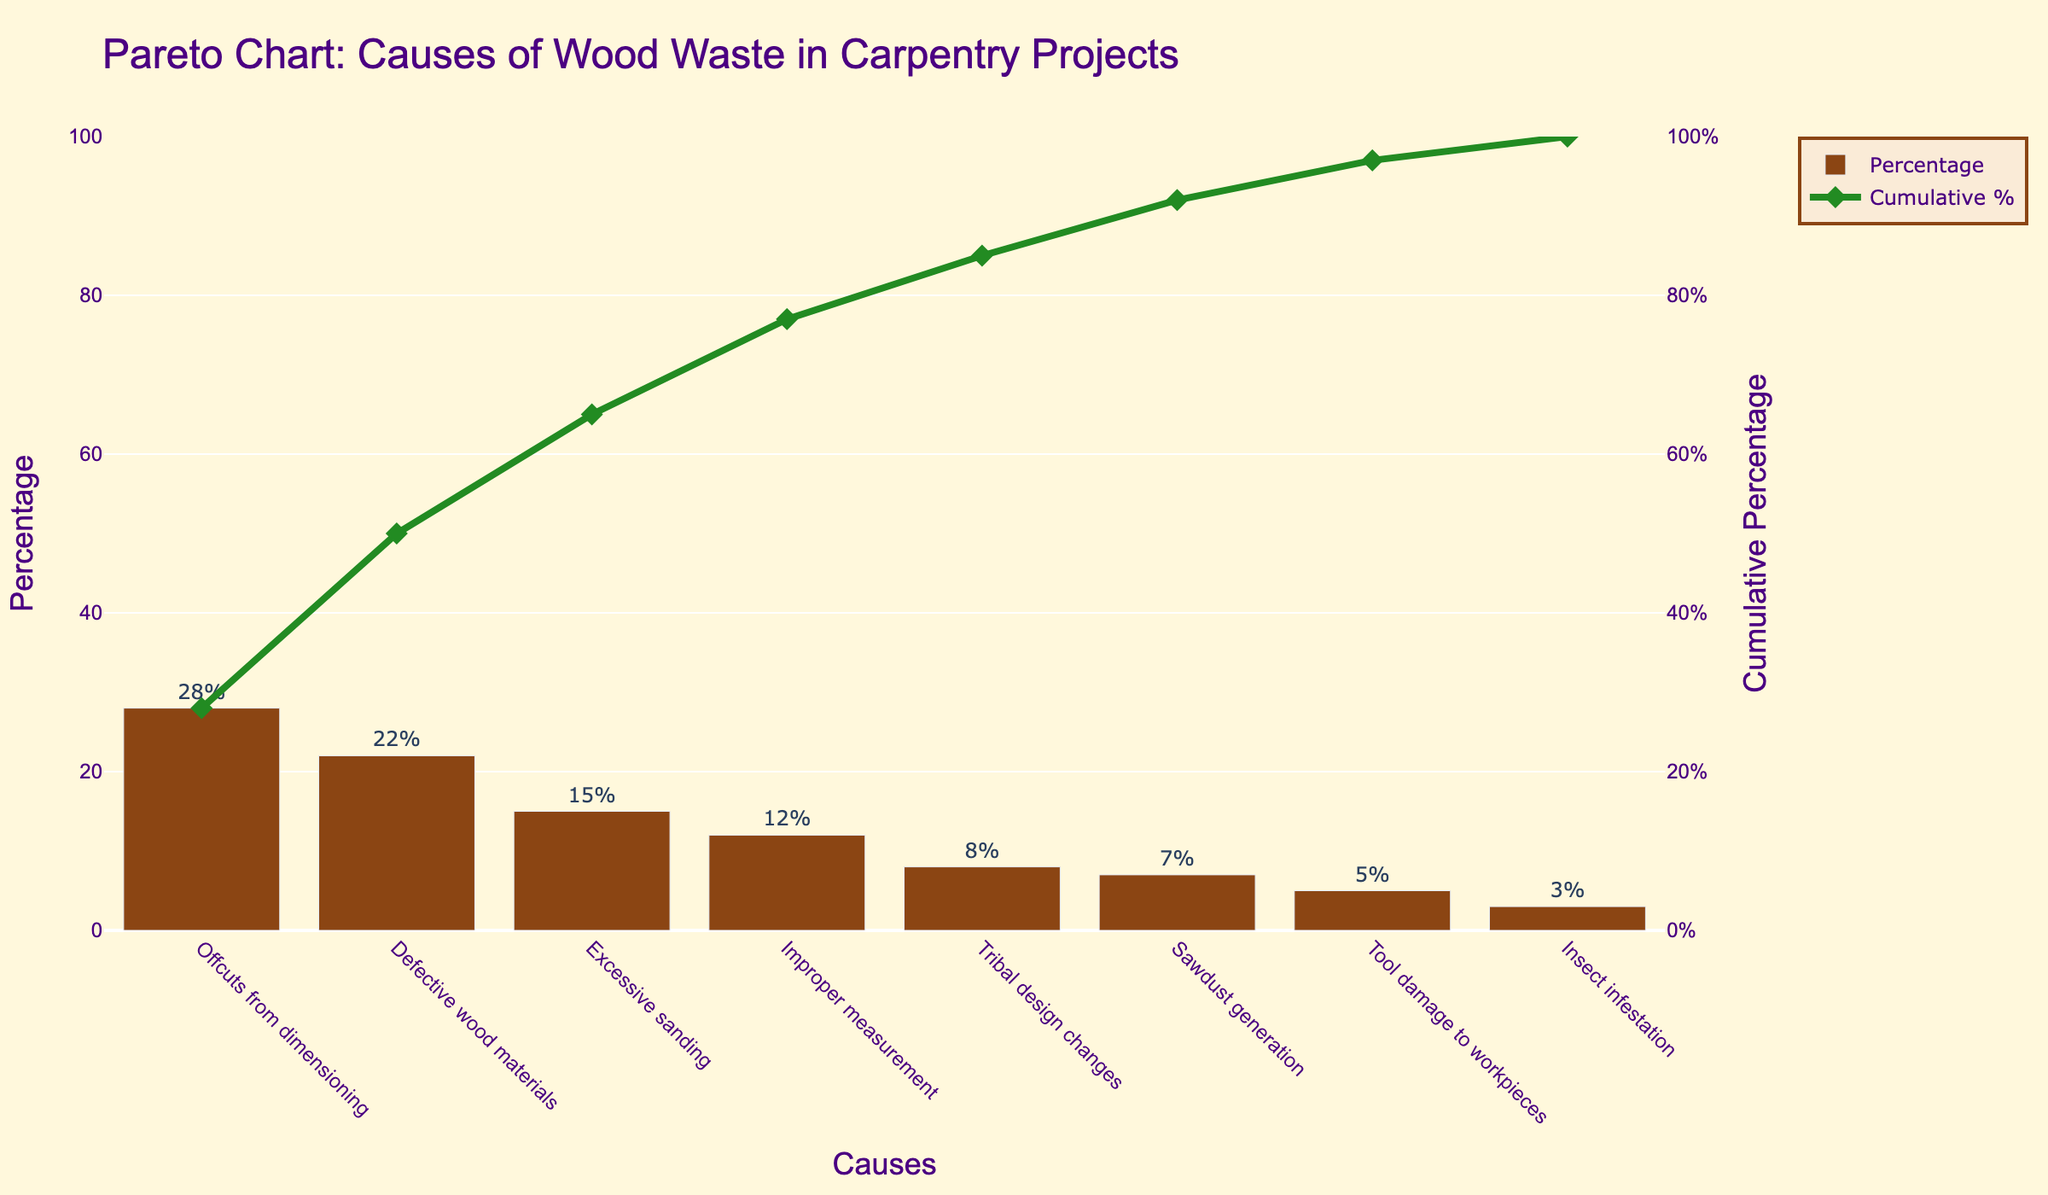Which cause of wood waste has the highest percentage? Offcuts from dimensioning has the highest percentage in the chart, as it is positioned first with 28%.
Answer: Offcuts from dimensioning What is the total cumulative percentage after accounting for the top three causes of wood waste? Add the percentages of the top three causes: Offcuts from dimensioning (28%), Defective wood materials (22%), and Excessive sanding (15%). 28 + 22 + 15 = 65%.
Answer: 65% How much higher is the percentage of Offcuts from dimensioning compared to Improper measurement? Subtract the percentage of Improper measurement (12%) from the percentage of Offcuts from dimensioning (28%). 28 - 12 = 16%.
Answer: 16% What percentage of wood waste is attributed to Excessive sanding? Refer to the bar representing Excessive sanding, which has a percentage label of 15%.
Answer: 15% Which causes contribute to at least 50% of the wood waste? Identify the causes until the cumulative percentage reaches 50%: Offcuts from dimensioning (28%) and Defective wood materials (22%). Their cumulative percentage is 28 + 22 = 50%.
Answer: Offcuts from dimensioning and Defective wood materials What is the cumulative percentage after including Sawdust generation? The cumulative percentage before Sawdust generation is 85% (including Tribal design changes). Adding Sawdust generation's 7%, we get 85 + 7 = 92%.
Answer: 92% Which cause contributes the least to wood waste? Insect infestation has the lowest percentage at 3%, as indicated by its position and label.
Answer: Insect infestation How do the percentages of Defective wood materials and Excessive sanding compare? The percentage of Defective wood materials (22%) is higher than that of Excessive sanding (15%).
Answer: 22% is higher Where does the cumulative percentage curve first exceed 75%? The cumulative percentage first exceeds 75% at Improper measurement, with a cumulative percentage of 77%.
Answer: Improper measurement What is the combined percentage of Tribal design changes and Tool damage to workpieces? Add the percentages of Tribal design changes (8%) and Tool damage to workpieces (5%). 8 + 5 = 13%.
Answer: 13% 